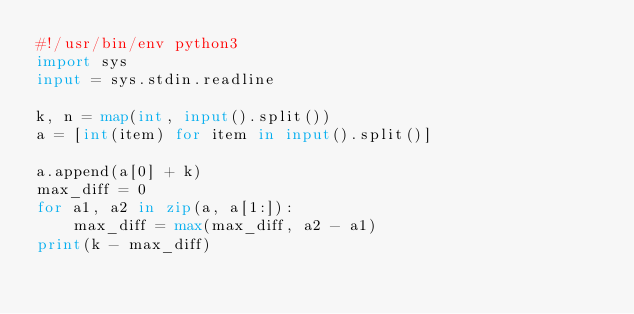<code> <loc_0><loc_0><loc_500><loc_500><_Python_>#!/usr/bin/env python3
import sys
input = sys.stdin.readline

k, n = map(int, input().split())
a = [int(item) for item in input().split()]

a.append(a[0] + k)
max_diff = 0
for a1, a2 in zip(a, a[1:]):
    max_diff = max(max_diff, a2 - a1)
print(k - max_diff)</code> 